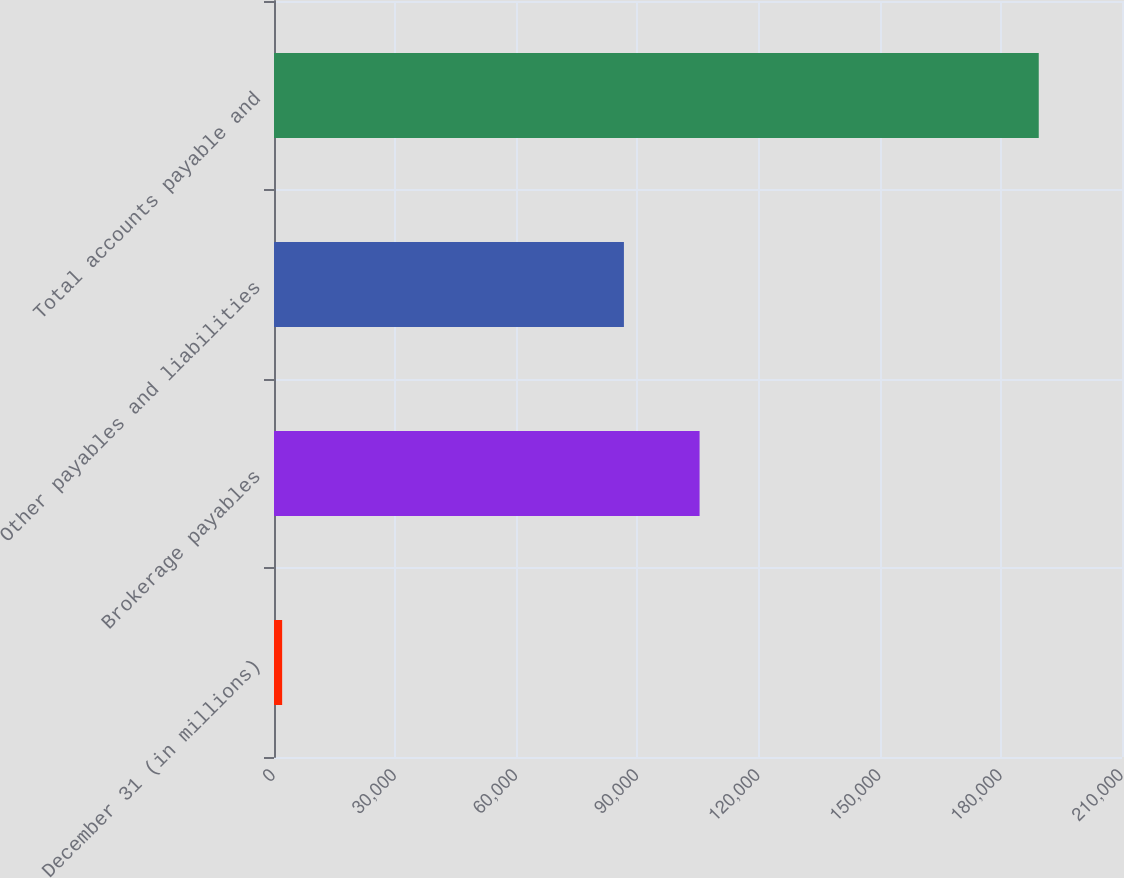<chart> <loc_0><loc_0><loc_500><loc_500><bar_chart><fcel>December 31 (in millions)<fcel>Brokerage payables<fcel>Other payables and liabilities<fcel>Total accounts payable and<nl><fcel>2017<fcel>105393<fcel>86656<fcel>189383<nl></chart> 